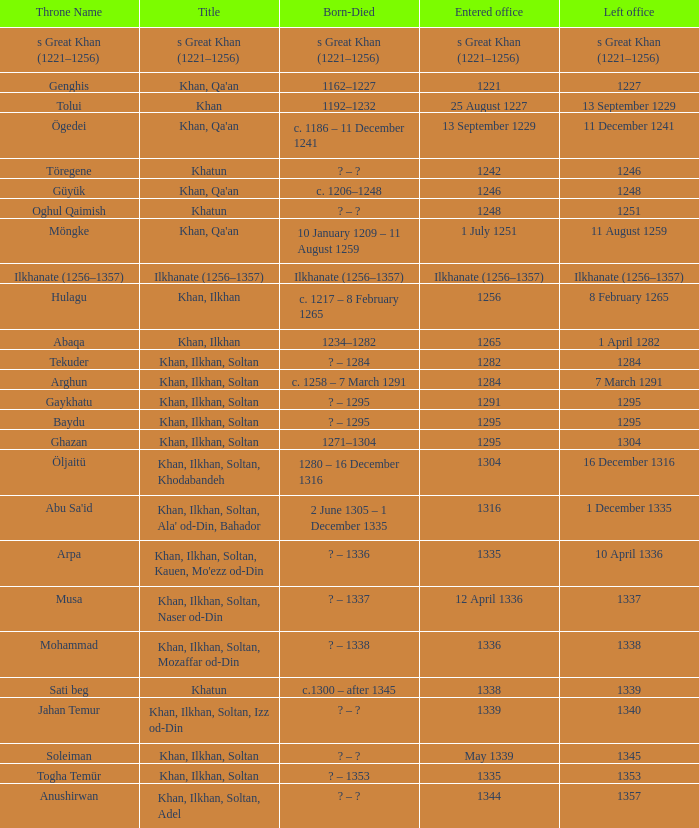Give me the full table as a dictionary. {'header': ['Throne Name', 'Title', 'Born-Died', 'Entered office', 'Left office'], 'rows': [['s Great Khan (1221–1256)', 's Great Khan (1221–1256)', 's Great Khan (1221–1256)', 's Great Khan (1221–1256)', 's Great Khan (1221–1256)'], ['Genghis', "Khan, Qa'an", '1162–1227', '1221', '1227'], ['Tolui', 'Khan', '1192–1232', '25 August 1227', '13 September 1229'], ['Ögedei', "Khan, Qa'an", 'c. 1186 – 11 December 1241', '13 September 1229', '11 December 1241'], ['Töregene', 'Khatun', '? – ?', '1242', '1246'], ['Güyük', "Khan, Qa'an", 'c. 1206–1248', '1246', '1248'], ['Oghul Qaimish', 'Khatun', '? – ?', '1248', '1251'], ['Möngke', "Khan, Qa'an", '10 January 1209 – 11 August 1259', '1 July 1251', '11 August 1259'], ['Ilkhanate (1256–1357)', 'Ilkhanate (1256–1357)', 'Ilkhanate (1256–1357)', 'Ilkhanate (1256–1357)', 'Ilkhanate (1256–1357)'], ['Hulagu', 'Khan, Ilkhan', 'c. 1217 – 8 February 1265', '1256', '8 February 1265'], ['Abaqa', 'Khan, Ilkhan', '1234–1282', '1265', '1 April 1282'], ['Tekuder', 'Khan, Ilkhan, Soltan', '? – 1284', '1282', '1284'], ['Arghun', 'Khan, Ilkhan, Soltan', 'c. 1258 – 7 March 1291', '1284', '7 March 1291'], ['Gaykhatu', 'Khan, Ilkhan, Soltan', '? – 1295', '1291', '1295'], ['Baydu', 'Khan, Ilkhan, Soltan', '? – 1295', '1295', '1295'], ['Ghazan', 'Khan, Ilkhan, Soltan', '1271–1304', '1295', '1304'], ['Öljaitü', 'Khan, Ilkhan, Soltan, Khodabandeh', '1280 – 16 December 1316', '1304', '16 December 1316'], ["Abu Sa'id", "Khan, Ilkhan, Soltan, Ala' od-Din, Bahador", '2 June 1305 – 1 December 1335', '1316', '1 December 1335'], ['Arpa', "Khan, Ilkhan, Soltan, Kauen, Mo'ezz od-Din", '? – 1336', '1335', '10 April 1336'], ['Musa', 'Khan, Ilkhan, Soltan, Naser od-Din', '? – 1337', '12 April 1336', '1337'], ['Mohammad', 'Khan, Ilkhan, Soltan, Mozaffar od-Din', '? – 1338', '1336', '1338'], ['Sati beg', 'Khatun', 'c.1300 – after 1345', '1338', '1339'], ['Jahan Temur', 'Khan, Ilkhan, Soltan, Izz od-Din', '? – ?', '1339', '1340'], ['Soleiman', 'Khan, Ilkhan, Soltan', '? – ?', 'May 1339', '1345'], ['Togha Temür', 'Khan, Ilkhan, Soltan', '? – 1353', '1335', '1353'], ['Anushirwan', 'Khan, Ilkhan, Soltan, Adel', '? – ?', '1344', '1357']]} What is the entered office that has 1337 as the left office? 12 April 1336. 